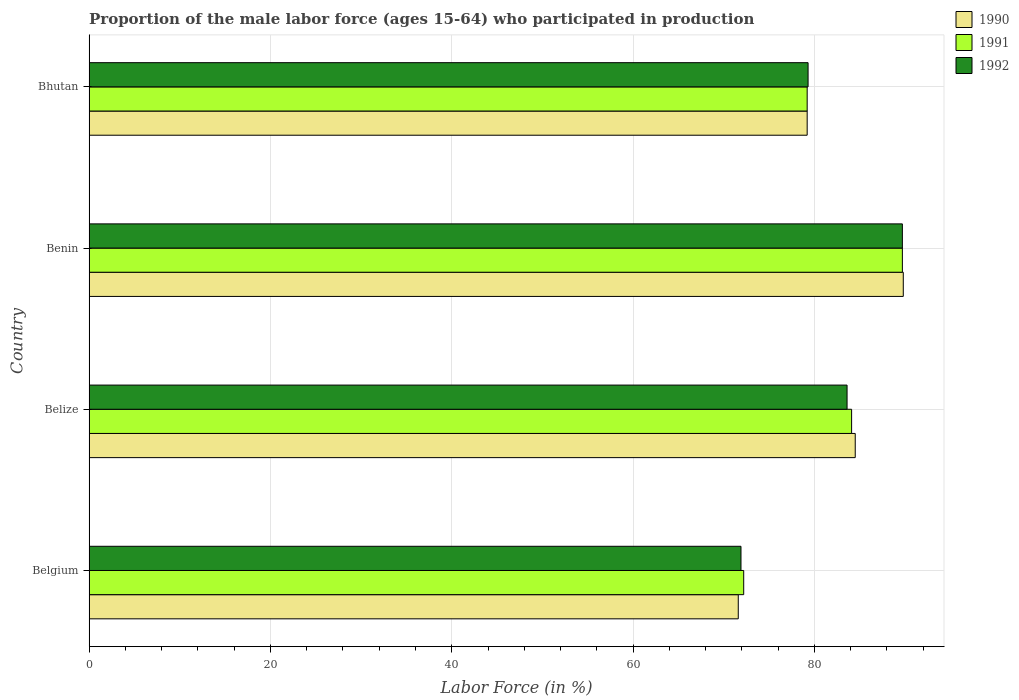Are the number of bars on each tick of the Y-axis equal?
Your answer should be very brief. Yes. What is the label of the 3rd group of bars from the top?
Keep it short and to the point. Belize. What is the proportion of the male labor force who participated in production in 1992 in Belgium?
Offer a very short reply. 71.9. Across all countries, what is the maximum proportion of the male labor force who participated in production in 1992?
Keep it short and to the point. 89.7. Across all countries, what is the minimum proportion of the male labor force who participated in production in 1990?
Ensure brevity in your answer.  71.6. In which country was the proportion of the male labor force who participated in production in 1992 maximum?
Your answer should be compact. Benin. What is the total proportion of the male labor force who participated in production in 1992 in the graph?
Your answer should be compact. 324.5. What is the difference between the proportion of the male labor force who participated in production in 1990 in Belize and that in Benin?
Provide a succinct answer. -5.3. What is the difference between the proportion of the male labor force who participated in production in 1992 in Bhutan and the proportion of the male labor force who participated in production in 1990 in Benin?
Your response must be concise. -10.5. What is the average proportion of the male labor force who participated in production in 1991 per country?
Offer a terse response. 81.3. What is the difference between the proportion of the male labor force who participated in production in 1990 and proportion of the male labor force who participated in production in 1991 in Benin?
Give a very brief answer. 0.1. What is the ratio of the proportion of the male labor force who participated in production in 1991 in Belize to that in Bhutan?
Your answer should be compact. 1.06. Is the proportion of the male labor force who participated in production in 1992 in Belize less than that in Bhutan?
Provide a short and direct response. No. Is the difference between the proportion of the male labor force who participated in production in 1990 in Belize and Benin greater than the difference between the proportion of the male labor force who participated in production in 1991 in Belize and Benin?
Make the answer very short. Yes. What is the difference between the highest and the second highest proportion of the male labor force who participated in production in 1992?
Your answer should be compact. 6.1. What is the difference between the highest and the lowest proportion of the male labor force who participated in production in 1992?
Offer a very short reply. 17.8. In how many countries, is the proportion of the male labor force who participated in production in 1990 greater than the average proportion of the male labor force who participated in production in 1990 taken over all countries?
Keep it short and to the point. 2. Is the sum of the proportion of the male labor force who participated in production in 1990 in Benin and Bhutan greater than the maximum proportion of the male labor force who participated in production in 1992 across all countries?
Your response must be concise. Yes. What does the 3rd bar from the top in Bhutan represents?
Give a very brief answer. 1990. What is the difference between two consecutive major ticks on the X-axis?
Your answer should be very brief. 20. Does the graph contain grids?
Your answer should be very brief. Yes. Where does the legend appear in the graph?
Your response must be concise. Top right. How many legend labels are there?
Provide a short and direct response. 3. What is the title of the graph?
Offer a very short reply. Proportion of the male labor force (ages 15-64) who participated in production. Does "2000" appear as one of the legend labels in the graph?
Provide a short and direct response. No. What is the Labor Force (in %) in 1990 in Belgium?
Make the answer very short. 71.6. What is the Labor Force (in %) of 1991 in Belgium?
Your response must be concise. 72.2. What is the Labor Force (in %) of 1992 in Belgium?
Your response must be concise. 71.9. What is the Labor Force (in %) in 1990 in Belize?
Give a very brief answer. 84.5. What is the Labor Force (in %) of 1991 in Belize?
Keep it short and to the point. 84.1. What is the Labor Force (in %) in 1992 in Belize?
Provide a succinct answer. 83.6. What is the Labor Force (in %) of 1990 in Benin?
Offer a terse response. 89.8. What is the Labor Force (in %) of 1991 in Benin?
Make the answer very short. 89.7. What is the Labor Force (in %) of 1992 in Benin?
Your answer should be compact. 89.7. What is the Labor Force (in %) of 1990 in Bhutan?
Your answer should be compact. 79.2. What is the Labor Force (in %) of 1991 in Bhutan?
Ensure brevity in your answer.  79.2. What is the Labor Force (in %) of 1992 in Bhutan?
Your answer should be compact. 79.3. Across all countries, what is the maximum Labor Force (in %) in 1990?
Give a very brief answer. 89.8. Across all countries, what is the maximum Labor Force (in %) of 1991?
Provide a succinct answer. 89.7. Across all countries, what is the maximum Labor Force (in %) of 1992?
Keep it short and to the point. 89.7. Across all countries, what is the minimum Labor Force (in %) of 1990?
Make the answer very short. 71.6. Across all countries, what is the minimum Labor Force (in %) in 1991?
Provide a succinct answer. 72.2. Across all countries, what is the minimum Labor Force (in %) in 1992?
Your answer should be compact. 71.9. What is the total Labor Force (in %) in 1990 in the graph?
Your response must be concise. 325.1. What is the total Labor Force (in %) in 1991 in the graph?
Provide a short and direct response. 325.2. What is the total Labor Force (in %) in 1992 in the graph?
Give a very brief answer. 324.5. What is the difference between the Labor Force (in %) in 1990 in Belgium and that in Belize?
Give a very brief answer. -12.9. What is the difference between the Labor Force (in %) of 1991 in Belgium and that in Belize?
Provide a succinct answer. -11.9. What is the difference between the Labor Force (in %) in 1992 in Belgium and that in Belize?
Make the answer very short. -11.7. What is the difference between the Labor Force (in %) of 1990 in Belgium and that in Benin?
Your response must be concise. -18.2. What is the difference between the Labor Force (in %) of 1991 in Belgium and that in Benin?
Make the answer very short. -17.5. What is the difference between the Labor Force (in %) in 1992 in Belgium and that in Benin?
Offer a very short reply. -17.8. What is the difference between the Labor Force (in %) in 1990 in Belgium and that in Bhutan?
Keep it short and to the point. -7.6. What is the difference between the Labor Force (in %) in 1990 in Belize and that in Benin?
Your response must be concise. -5.3. What is the difference between the Labor Force (in %) in 1990 in Belize and that in Bhutan?
Keep it short and to the point. 5.3. What is the difference between the Labor Force (in %) in 1991 in Benin and that in Bhutan?
Keep it short and to the point. 10.5. What is the difference between the Labor Force (in %) in 1990 in Belgium and the Labor Force (in %) in 1991 in Belize?
Ensure brevity in your answer.  -12.5. What is the difference between the Labor Force (in %) in 1991 in Belgium and the Labor Force (in %) in 1992 in Belize?
Your response must be concise. -11.4. What is the difference between the Labor Force (in %) in 1990 in Belgium and the Labor Force (in %) in 1991 in Benin?
Give a very brief answer. -18.1. What is the difference between the Labor Force (in %) of 1990 in Belgium and the Labor Force (in %) of 1992 in Benin?
Offer a very short reply. -18.1. What is the difference between the Labor Force (in %) of 1991 in Belgium and the Labor Force (in %) of 1992 in Benin?
Your answer should be very brief. -17.5. What is the difference between the Labor Force (in %) in 1990 in Belgium and the Labor Force (in %) in 1992 in Bhutan?
Your answer should be very brief. -7.7. What is the difference between the Labor Force (in %) of 1990 in Belize and the Labor Force (in %) of 1991 in Benin?
Your answer should be very brief. -5.2. What is the difference between the Labor Force (in %) in 1990 in Belize and the Labor Force (in %) in 1992 in Benin?
Your answer should be compact. -5.2. What is the difference between the Labor Force (in %) of 1990 in Belize and the Labor Force (in %) of 1992 in Bhutan?
Your answer should be very brief. 5.2. What is the difference between the Labor Force (in %) of 1990 in Benin and the Labor Force (in %) of 1992 in Bhutan?
Offer a terse response. 10.5. What is the difference between the Labor Force (in %) in 1991 in Benin and the Labor Force (in %) in 1992 in Bhutan?
Provide a short and direct response. 10.4. What is the average Labor Force (in %) in 1990 per country?
Offer a very short reply. 81.28. What is the average Labor Force (in %) of 1991 per country?
Offer a very short reply. 81.3. What is the average Labor Force (in %) of 1992 per country?
Your answer should be very brief. 81.12. What is the difference between the Labor Force (in %) of 1990 and Labor Force (in %) of 1991 in Belgium?
Your response must be concise. -0.6. What is the difference between the Labor Force (in %) of 1990 and Labor Force (in %) of 1992 in Belgium?
Ensure brevity in your answer.  -0.3. What is the difference between the Labor Force (in %) in 1990 and Labor Force (in %) in 1992 in Belize?
Give a very brief answer. 0.9. What is the difference between the Labor Force (in %) of 1991 and Labor Force (in %) of 1992 in Belize?
Keep it short and to the point. 0.5. What is the difference between the Labor Force (in %) in 1990 and Labor Force (in %) in 1991 in Bhutan?
Ensure brevity in your answer.  0. What is the difference between the Labor Force (in %) in 1990 and Labor Force (in %) in 1992 in Bhutan?
Your answer should be compact. -0.1. What is the ratio of the Labor Force (in %) of 1990 in Belgium to that in Belize?
Provide a short and direct response. 0.85. What is the ratio of the Labor Force (in %) of 1991 in Belgium to that in Belize?
Provide a short and direct response. 0.86. What is the ratio of the Labor Force (in %) of 1992 in Belgium to that in Belize?
Make the answer very short. 0.86. What is the ratio of the Labor Force (in %) of 1990 in Belgium to that in Benin?
Ensure brevity in your answer.  0.8. What is the ratio of the Labor Force (in %) in 1991 in Belgium to that in Benin?
Offer a terse response. 0.8. What is the ratio of the Labor Force (in %) of 1992 in Belgium to that in Benin?
Keep it short and to the point. 0.8. What is the ratio of the Labor Force (in %) of 1990 in Belgium to that in Bhutan?
Provide a succinct answer. 0.9. What is the ratio of the Labor Force (in %) of 1991 in Belgium to that in Bhutan?
Your response must be concise. 0.91. What is the ratio of the Labor Force (in %) in 1992 in Belgium to that in Bhutan?
Provide a succinct answer. 0.91. What is the ratio of the Labor Force (in %) in 1990 in Belize to that in Benin?
Offer a terse response. 0.94. What is the ratio of the Labor Force (in %) in 1991 in Belize to that in Benin?
Provide a succinct answer. 0.94. What is the ratio of the Labor Force (in %) in 1992 in Belize to that in Benin?
Your answer should be very brief. 0.93. What is the ratio of the Labor Force (in %) in 1990 in Belize to that in Bhutan?
Offer a very short reply. 1.07. What is the ratio of the Labor Force (in %) of 1991 in Belize to that in Bhutan?
Offer a terse response. 1.06. What is the ratio of the Labor Force (in %) in 1992 in Belize to that in Bhutan?
Offer a very short reply. 1.05. What is the ratio of the Labor Force (in %) of 1990 in Benin to that in Bhutan?
Provide a short and direct response. 1.13. What is the ratio of the Labor Force (in %) of 1991 in Benin to that in Bhutan?
Ensure brevity in your answer.  1.13. What is the ratio of the Labor Force (in %) of 1992 in Benin to that in Bhutan?
Offer a terse response. 1.13. What is the difference between the highest and the second highest Labor Force (in %) in 1991?
Your response must be concise. 5.6. What is the difference between the highest and the second highest Labor Force (in %) in 1992?
Make the answer very short. 6.1. What is the difference between the highest and the lowest Labor Force (in %) of 1991?
Make the answer very short. 17.5. What is the difference between the highest and the lowest Labor Force (in %) in 1992?
Provide a succinct answer. 17.8. 